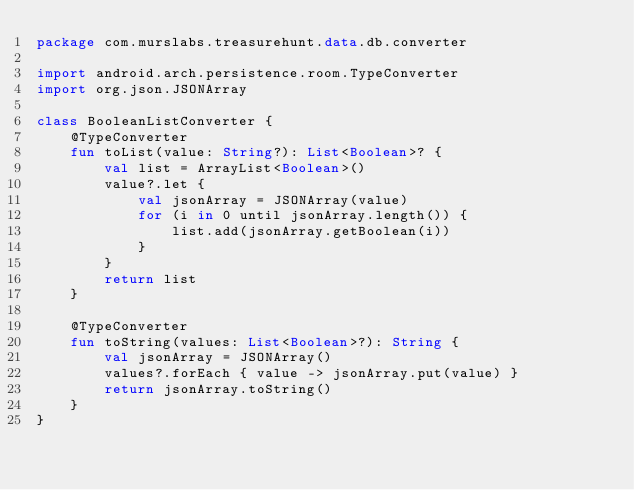<code> <loc_0><loc_0><loc_500><loc_500><_Kotlin_>package com.murslabs.treasurehunt.data.db.converter

import android.arch.persistence.room.TypeConverter
import org.json.JSONArray

class BooleanListConverter {
    @TypeConverter
    fun toList(value: String?): List<Boolean>? {
        val list = ArrayList<Boolean>()
        value?.let {
            val jsonArray = JSONArray(value)
            for (i in 0 until jsonArray.length()) {
                list.add(jsonArray.getBoolean(i))
            }
        }
        return list
    }

    @TypeConverter
    fun toString(values: List<Boolean>?): String {
        val jsonArray = JSONArray()
        values?.forEach { value -> jsonArray.put(value) }
        return jsonArray.toString()
    }
}</code> 